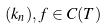Convert formula to latex. <formula><loc_0><loc_0><loc_500><loc_500>( k _ { n } ) , f \in C ( T )</formula> 